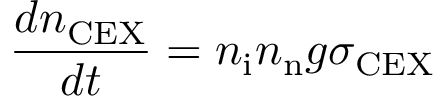<formula> <loc_0><loc_0><loc_500><loc_500>\frac { d n _ { C E X } } { d t } = n _ { i } n _ { n } g \sigma _ { C E X }</formula> 